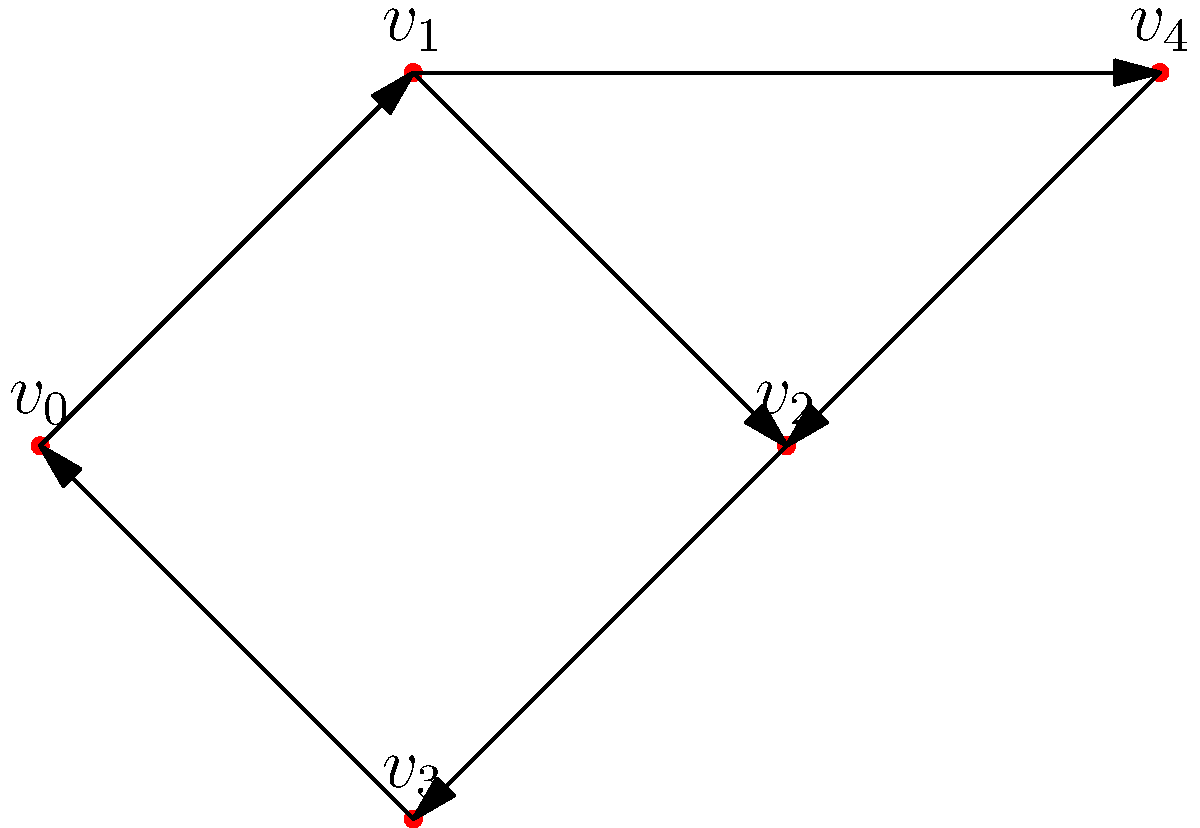Consider the directed graph shown above. You've implemented a depth-first search (DFS) algorithm to detect cycles in this graph. Starting from vertex $v_0$, in which order should the vertices be visited to detect a cycle as quickly as possible? Let's analyze the graph and apply the depth-first search algorithm step by step:

1. We start at vertex $v_0$.

2. From $v_0$, we visit $v_1$ (the only outgoing edge from $v_0$).

3. From $v_1$, we have two choices: $v_2$ or $v_4$. Let's choose $v_2$ to detect the cycle faster.

4. From $v_2$, we visit $v_3$.

5. From $v_3$, we visit $v_0$.

At this point, we've detected a cycle because we've returned to a vertex ($v_0$) that we've already visited.

The order of vertices visited is: $v_0 \rightarrow v_1 \rightarrow v_2 \rightarrow v_3 \rightarrow v_0$

This path forms the cycle $v_0 \rightarrow v_1 \rightarrow v_2 \rightarrow v_3 \rightarrow v_0$, which is detected as quickly as possible given the starting vertex.

Note: We didn't need to visit $v_4$ to detect this cycle.
Answer: $v_0, v_1, v_2, v_3, v_0$ 